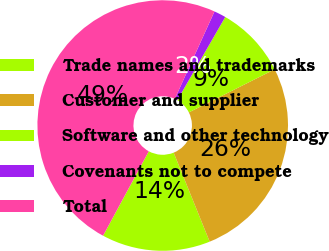Convert chart to OTSL. <chart><loc_0><loc_0><loc_500><loc_500><pie_chart><fcel>Trade names and trademarks<fcel>Customer and supplier<fcel>Software and other technology<fcel>Covenants not to compete<fcel>Total<nl><fcel>14.01%<fcel>26.29%<fcel>9.27%<fcel>1.54%<fcel>48.89%<nl></chart> 